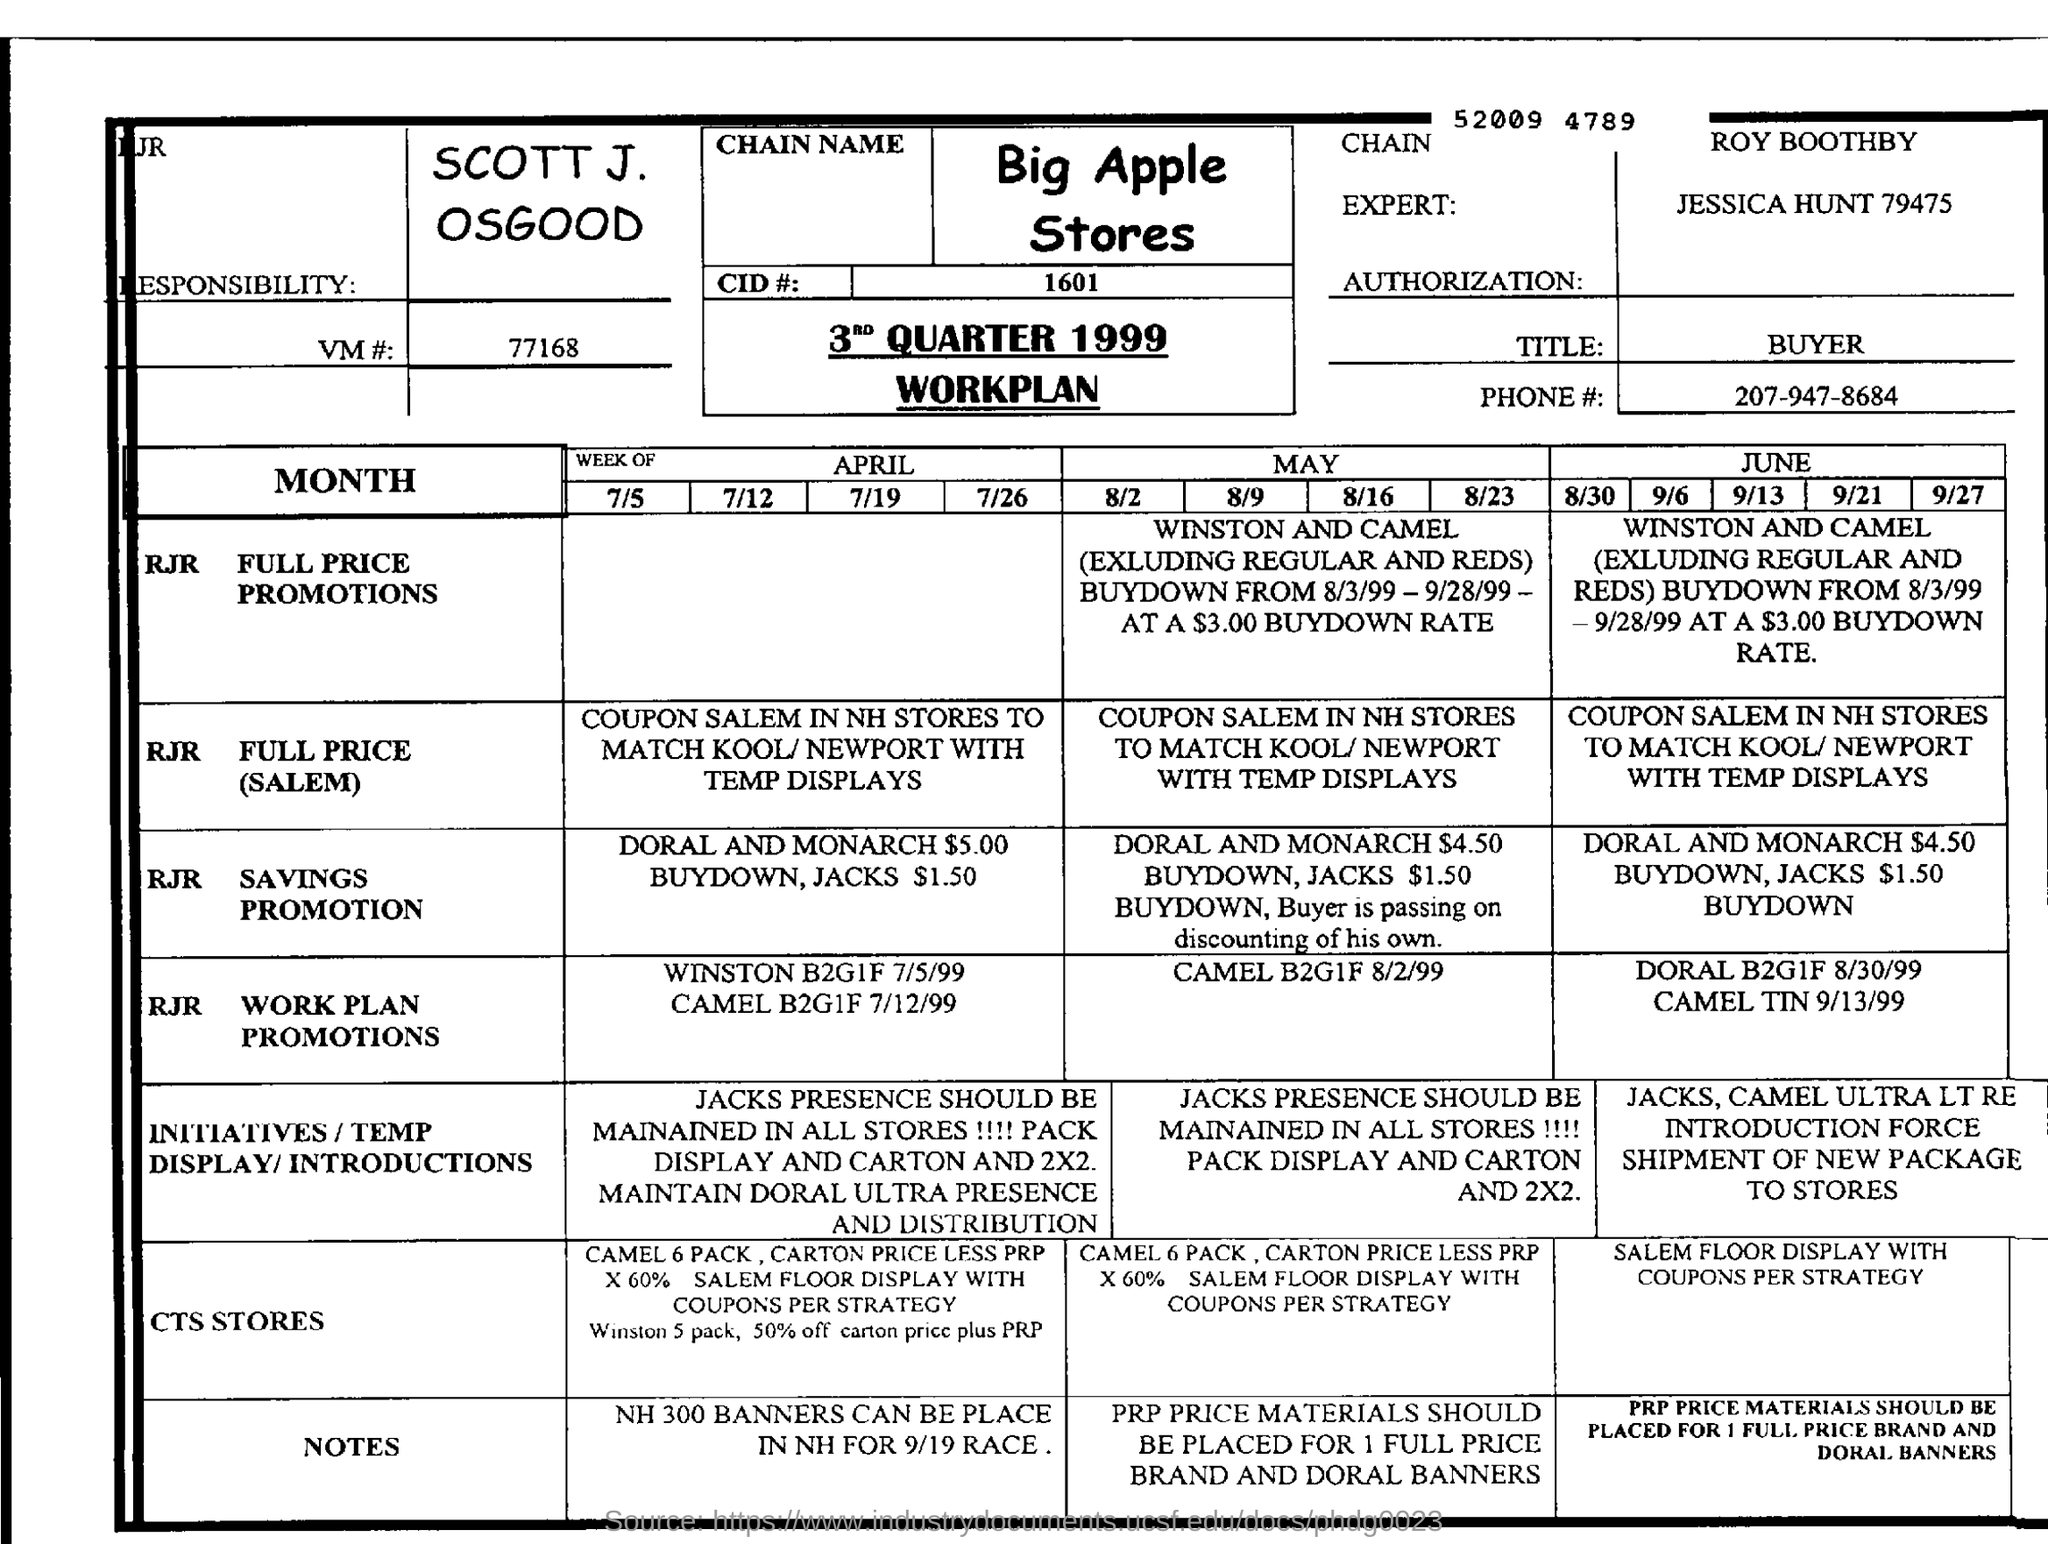Outline some significant characteristics in this image. The title of the buyer... The VM# mentioned in the form is 77168. This document is the 3rd Quarter Workplan for the year 1999. The name of the store is Big Apple Stores. 